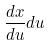<formula> <loc_0><loc_0><loc_500><loc_500>\frac { d x } { d u } d u</formula> 